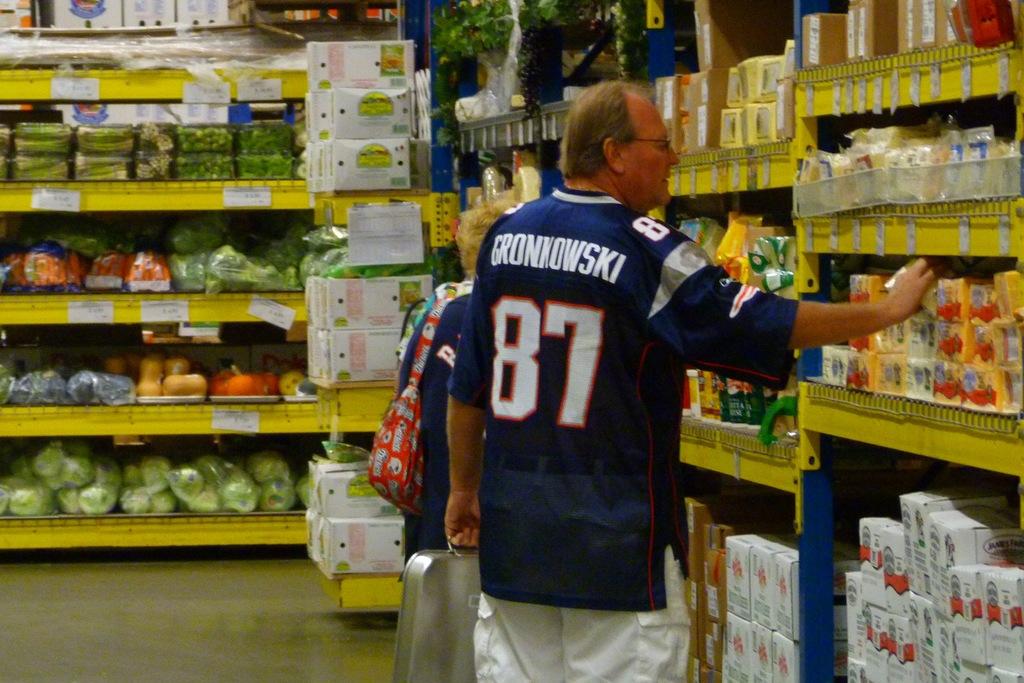Whose jersey is the man wearing?
Your answer should be very brief. Gronkowski. What is the players number on the jersey?
Give a very brief answer. 87. 